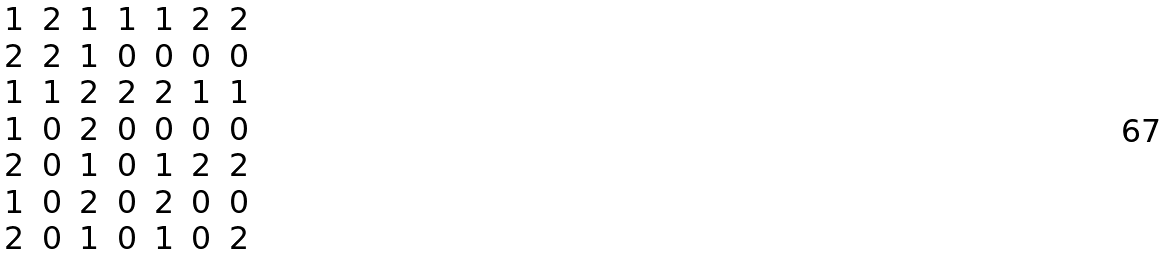Convert formula to latex. <formula><loc_0><loc_0><loc_500><loc_500>\begin{matrix} 1 & 2 & 1 & 1 & 1 & 2 & 2 \\ 2 & 2 & 1 & 0 & 0 & 0 & 0 \\ 1 & 1 & 2 & 2 & 2 & 1 & 1 \\ 1 & 0 & 2 & 0 & 0 & 0 & 0 \\ 2 & 0 & 1 & 0 & 1 & 2 & 2 \\ 1 & 0 & 2 & 0 & 2 & 0 & 0 \\ 2 & 0 & 1 & 0 & 1 & 0 & 2 \end{matrix}</formula> 